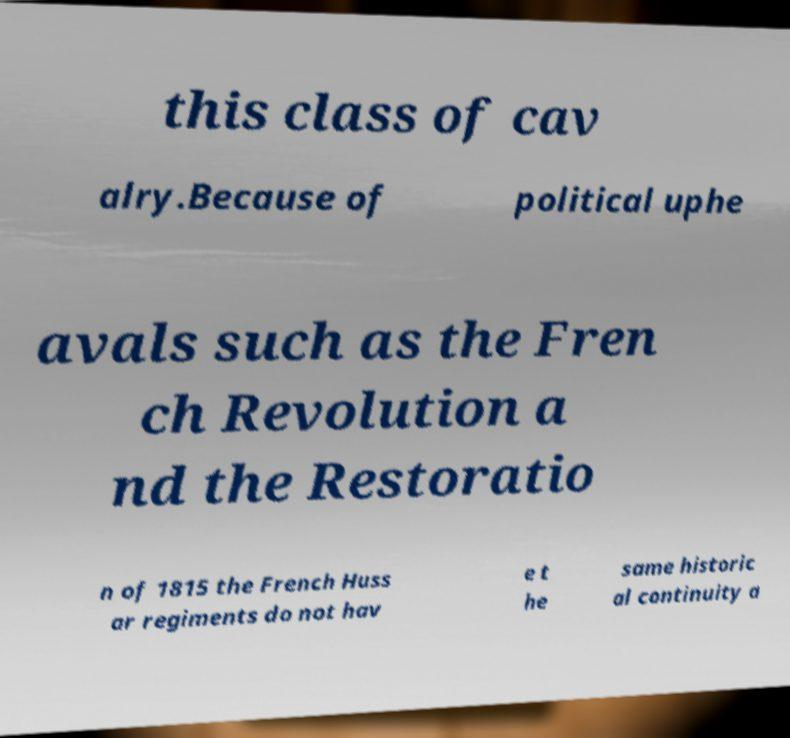What messages or text are displayed in this image? I need them in a readable, typed format. this class of cav alry.Because of political uphe avals such as the Fren ch Revolution a nd the Restoratio n of 1815 the French Huss ar regiments do not hav e t he same historic al continuity a 